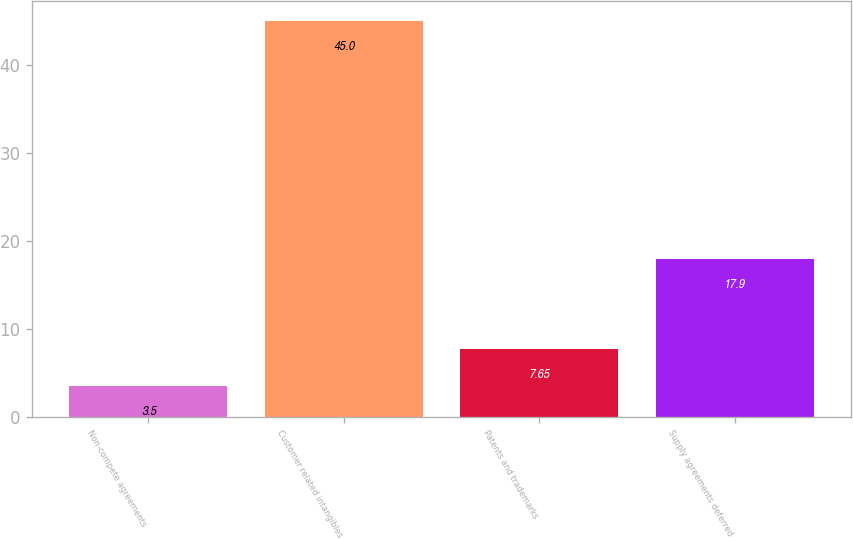<chart> <loc_0><loc_0><loc_500><loc_500><bar_chart><fcel>Non-compete agreements<fcel>Customer related intangibles<fcel>Patents and trademarks<fcel>Supply agreements deferred<nl><fcel>3.5<fcel>45<fcel>7.65<fcel>17.9<nl></chart> 